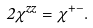Convert formula to latex. <formula><loc_0><loc_0><loc_500><loc_500>2 \chi ^ { z z } = \chi ^ { + - } .</formula> 